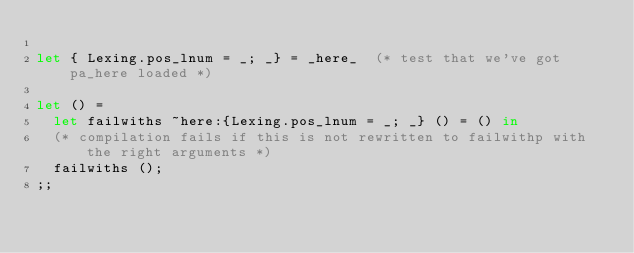<code> <loc_0><loc_0><loc_500><loc_500><_OCaml_>
let { Lexing.pos_lnum = _; _} = _here_  (* test that we've got pa_here loaded *)

let () =
  let failwiths ~here:{Lexing.pos_lnum = _; _} () = () in
  (* compilation fails if this is not rewritten to failwithp with the right arguments *)
  failwiths ();
;;
</code> 